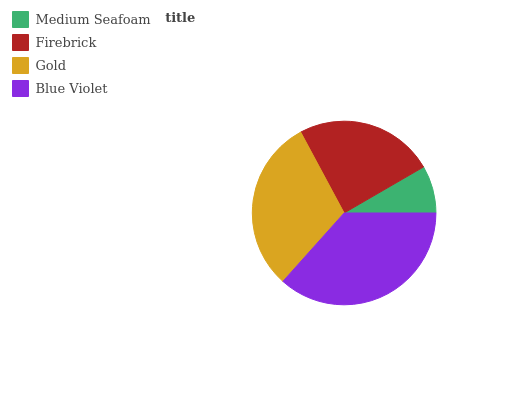Is Medium Seafoam the minimum?
Answer yes or no. Yes. Is Blue Violet the maximum?
Answer yes or no. Yes. Is Firebrick the minimum?
Answer yes or no. No. Is Firebrick the maximum?
Answer yes or no. No. Is Firebrick greater than Medium Seafoam?
Answer yes or no. Yes. Is Medium Seafoam less than Firebrick?
Answer yes or no. Yes. Is Medium Seafoam greater than Firebrick?
Answer yes or no. No. Is Firebrick less than Medium Seafoam?
Answer yes or no. No. Is Gold the high median?
Answer yes or no. Yes. Is Firebrick the low median?
Answer yes or no. Yes. Is Firebrick the high median?
Answer yes or no. No. Is Blue Violet the low median?
Answer yes or no. No. 